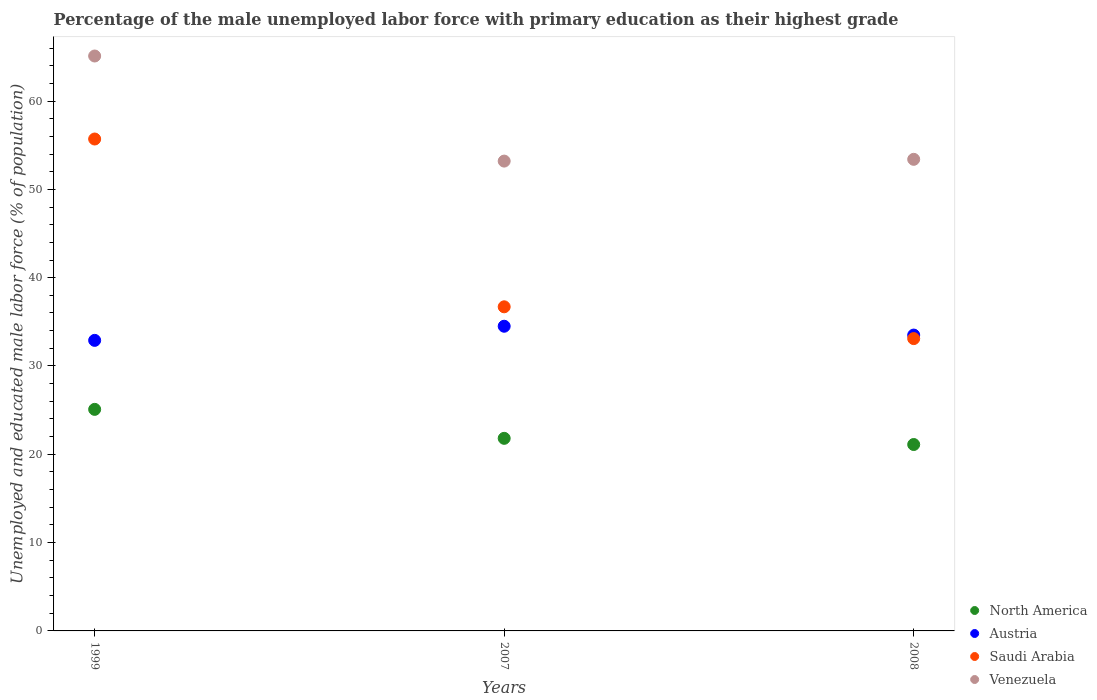What is the percentage of the unemployed male labor force with primary education in Austria in 1999?
Your answer should be compact. 32.9. Across all years, what is the maximum percentage of the unemployed male labor force with primary education in Venezuela?
Make the answer very short. 65.1. Across all years, what is the minimum percentage of the unemployed male labor force with primary education in Saudi Arabia?
Provide a succinct answer. 33.1. What is the total percentage of the unemployed male labor force with primary education in Saudi Arabia in the graph?
Offer a terse response. 125.5. What is the difference between the percentage of the unemployed male labor force with primary education in Austria in 1999 and that in 2008?
Provide a succinct answer. -0.6. What is the difference between the percentage of the unemployed male labor force with primary education in Venezuela in 2007 and the percentage of the unemployed male labor force with primary education in North America in 2008?
Offer a very short reply. 32.09. What is the average percentage of the unemployed male labor force with primary education in North America per year?
Your answer should be compact. 22.67. In the year 2008, what is the difference between the percentage of the unemployed male labor force with primary education in Venezuela and percentage of the unemployed male labor force with primary education in Saudi Arabia?
Provide a succinct answer. 20.3. In how many years, is the percentage of the unemployed male labor force with primary education in Saudi Arabia greater than 30 %?
Give a very brief answer. 3. What is the ratio of the percentage of the unemployed male labor force with primary education in Austria in 1999 to that in 2008?
Your answer should be compact. 0.98. Is the difference between the percentage of the unemployed male labor force with primary education in Venezuela in 2007 and 2008 greater than the difference between the percentage of the unemployed male labor force with primary education in Saudi Arabia in 2007 and 2008?
Provide a short and direct response. No. What is the difference between the highest and the second highest percentage of the unemployed male labor force with primary education in North America?
Keep it short and to the point. 3.28. What is the difference between the highest and the lowest percentage of the unemployed male labor force with primary education in North America?
Your answer should be compact. 3.98. In how many years, is the percentage of the unemployed male labor force with primary education in Venezuela greater than the average percentage of the unemployed male labor force with primary education in Venezuela taken over all years?
Your answer should be compact. 1. Is it the case that in every year, the sum of the percentage of the unemployed male labor force with primary education in Saudi Arabia and percentage of the unemployed male labor force with primary education in Austria  is greater than the sum of percentage of the unemployed male labor force with primary education in Venezuela and percentage of the unemployed male labor force with primary education in North America?
Your answer should be very brief. No. Is it the case that in every year, the sum of the percentage of the unemployed male labor force with primary education in Venezuela and percentage of the unemployed male labor force with primary education in Austria  is greater than the percentage of the unemployed male labor force with primary education in North America?
Offer a terse response. Yes. How many years are there in the graph?
Provide a short and direct response. 3. Are the values on the major ticks of Y-axis written in scientific E-notation?
Your response must be concise. No. How many legend labels are there?
Give a very brief answer. 4. How are the legend labels stacked?
Provide a short and direct response. Vertical. What is the title of the graph?
Your response must be concise. Percentage of the male unemployed labor force with primary education as their highest grade. Does "Liechtenstein" appear as one of the legend labels in the graph?
Offer a very short reply. No. What is the label or title of the Y-axis?
Provide a short and direct response. Unemployed and educated male labor force (% of population). What is the Unemployed and educated male labor force (% of population) of North America in 1999?
Give a very brief answer. 25.09. What is the Unemployed and educated male labor force (% of population) in Austria in 1999?
Provide a short and direct response. 32.9. What is the Unemployed and educated male labor force (% of population) in Saudi Arabia in 1999?
Your answer should be compact. 55.7. What is the Unemployed and educated male labor force (% of population) in Venezuela in 1999?
Make the answer very short. 65.1. What is the Unemployed and educated male labor force (% of population) in North America in 2007?
Provide a succinct answer. 21.81. What is the Unemployed and educated male labor force (% of population) of Austria in 2007?
Offer a terse response. 34.5. What is the Unemployed and educated male labor force (% of population) in Saudi Arabia in 2007?
Provide a short and direct response. 36.7. What is the Unemployed and educated male labor force (% of population) of Venezuela in 2007?
Provide a succinct answer. 53.2. What is the Unemployed and educated male labor force (% of population) in North America in 2008?
Make the answer very short. 21.11. What is the Unemployed and educated male labor force (% of population) of Austria in 2008?
Make the answer very short. 33.5. What is the Unemployed and educated male labor force (% of population) in Saudi Arabia in 2008?
Your answer should be compact. 33.1. What is the Unemployed and educated male labor force (% of population) of Venezuela in 2008?
Provide a succinct answer. 53.4. Across all years, what is the maximum Unemployed and educated male labor force (% of population) in North America?
Offer a terse response. 25.09. Across all years, what is the maximum Unemployed and educated male labor force (% of population) in Austria?
Make the answer very short. 34.5. Across all years, what is the maximum Unemployed and educated male labor force (% of population) of Saudi Arabia?
Your response must be concise. 55.7. Across all years, what is the maximum Unemployed and educated male labor force (% of population) in Venezuela?
Keep it short and to the point. 65.1. Across all years, what is the minimum Unemployed and educated male labor force (% of population) in North America?
Offer a very short reply. 21.11. Across all years, what is the minimum Unemployed and educated male labor force (% of population) in Austria?
Your answer should be compact. 32.9. Across all years, what is the minimum Unemployed and educated male labor force (% of population) of Saudi Arabia?
Keep it short and to the point. 33.1. Across all years, what is the minimum Unemployed and educated male labor force (% of population) of Venezuela?
Offer a very short reply. 53.2. What is the total Unemployed and educated male labor force (% of population) in North America in the graph?
Your answer should be very brief. 68. What is the total Unemployed and educated male labor force (% of population) of Austria in the graph?
Make the answer very short. 100.9. What is the total Unemployed and educated male labor force (% of population) in Saudi Arabia in the graph?
Ensure brevity in your answer.  125.5. What is the total Unemployed and educated male labor force (% of population) in Venezuela in the graph?
Make the answer very short. 171.7. What is the difference between the Unemployed and educated male labor force (% of population) in North America in 1999 and that in 2007?
Ensure brevity in your answer.  3.28. What is the difference between the Unemployed and educated male labor force (% of population) in Austria in 1999 and that in 2007?
Provide a succinct answer. -1.6. What is the difference between the Unemployed and educated male labor force (% of population) in Saudi Arabia in 1999 and that in 2007?
Your response must be concise. 19. What is the difference between the Unemployed and educated male labor force (% of population) in Venezuela in 1999 and that in 2007?
Make the answer very short. 11.9. What is the difference between the Unemployed and educated male labor force (% of population) of North America in 1999 and that in 2008?
Ensure brevity in your answer.  3.98. What is the difference between the Unemployed and educated male labor force (% of population) in Saudi Arabia in 1999 and that in 2008?
Your answer should be compact. 22.6. What is the difference between the Unemployed and educated male labor force (% of population) in North America in 2007 and that in 2008?
Ensure brevity in your answer.  0.7. What is the difference between the Unemployed and educated male labor force (% of population) in Austria in 2007 and that in 2008?
Provide a succinct answer. 1. What is the difference between the Unemployed and educated male labor force (% of population) of Saudi Arabia in 2007 and that in 2008?
Provide a succinct answer. 3.6. What is the difference between the Unemployed and educated male labor force (% of population) in Venezuela in 2007 and that in 2008?
Your response must be concise. -0.2. What is the difference between the Unemployed and educated male labor force (% of population) of North America in 1999 and the Unemployed and educated male labor force (% of population) of Austria in 2007?
Provide a short and direct response. -9.41. What is the difference between the Unemployed and educated male labor force (% of population) in North America in 1999 and the Unemployed and educated male labor force (% of population) in Saudi Arabia in 2007?
Offer a terse response. -11.61. What is the difference between the Unemployed and educated male labor force (% of population) of North America in 1999 and the Unemployed and educated male labor force (% of population) of Venezuela in 2007?
Provide a succinct answer. -28.11. What is the difference between the Unemployed and educated male labor force (% of population) in Austria in 1999 and the Unemployed and educated male labor force (% of population) in Saudi Arabia in 2007?
Give a very brief answer. -3.8. What is the difference between the Unemployed and educated male labor force (% of population) of Austria in 1999 and the Unemployed and educated male labor force (% of population) of Venezuela in 2007?
Give a very brief answer. -20.3. What is the difference between the Unemployed and educated male labor force (% of population) of Saudi Arabia in 1999 and the Unemployed and educated male labor force (% of population) of Venezuela in 2007?
Give a very brief answer. 2.5. What is the difference between the Unemployed and educated male labor force (% of population) in North America in 1999 and the Unemployed and educated male labor force (% of population) in Austria in 2008?
Your response must be concise. -8.41. What is the difference between the Unemployed and educated male labor force (% of population) in North America in 1999 and the Unemployed and educated male labor force (% of population) in Saudi Arabia in 2008?
Ensure brevity in your answer.  -8.01. What is the difference between the Unemployed and educated male labor force (% of population) of North America in 1999 and the Unemployed and educated male labor force (% of population) of Venezuela in 2008?
Give a very brief answer. -28.31. What is the difference between the Unemployed and educated male labor force (% of population) of Austria in 1999 and the Unemployed and educated male labor force (% of population) of Saudi Arabia in 2008?
Keep it short and to the point. -0.2. What is the difference between the Unemployed and educated male labor force (% of population) in Austria in 1999 and the Unemployed and educated male labor force (% of population) in Venezuela in 2008?
Your answer should be compact. -20.5. What is the difference between the Unemployed and educated male labor force (% of population) of Saudi Arabia in 1999 and the Unemployed and educated male labor force (% of population) of Venezuela in 2008?
Your answer should be compact. 2.3. What is the difference between the Unemployed and educated male labor force (% of population) of North America in 2007 and the Unemployed and educated male labor force (% of population) of Austria in 2008?
Give a very brief answer. -11.69. What is the difference between the Unemployed and educated male labor force (% of population) of North America in 2007 and the Unemployed and educated male labor force (% of population) of Saudi Arabia in 2008?
Your answer should be compact. -11.29. What is the difference between the Unemployed and educated male labor force (% of population) in North America in 2007 and the Unemployed and educated male labor force (% of population) in Venezuela in 2008?
Give a very brief answer. -31.59. What is the difference between the Unemployed and educated male labor force (% of population) of Austria in 2007 and the Unemployed and educated male labor force (% of population) of Saudi Arabia in 2008?
Make the answer very short. 1.4. What is the difference between the Unemployed and educated male labor force (% of population) in Austria in 2007 and the Unemployed and educated male labor force (% of population) in Venezuela in 2008?
Give a very brief answer. -18.9. What is the difference between the Unemployed and educated male labor force (% of population) of Saudi Arabia in 2007 and the Unemployed and educated male labor force (% of population) of Venezuela in 2008?
Offer a very short reply. -16.7. What is the average Unemployed and educated male labor force (% of population) of North America per year?
Ensure brevity in your answer.  22.67. What is the average Unemployed and educated male labor force (% of population) in Austria per year?
Ensure brevity in your answer.  33.63. What is the average Unemployed and educated male labor force (% of population) in Saudi Arabia per year?
Your answer should be compact. 41.83. What is the average Unemployed and educated male labor force (% of population) in Venezuela per year?
Keep it short and to the point. 57.23. In the year 1999, what is the difference between the Unemployed and educated male labor force (% of population) of North America and Unemployed and educated male labor force (% of population) of Austria?
Provide a short and direct response. -7.81. In the year 1999, what is the difference between the Unemployed and educated male labor force (% of population) in North America and Unemployed and educated male labor force (% of population) in Saudi Arabia?
Provide a short and direct response. -30.61. In the year 1999, what is the difference between the Unemployed and educated male labor force (% of population) of North America and Unemployed and educated male labor force (% of population) of Venezuela?
Give a very brief answer. -40.01. In the year 1999, what is the difference between the Unemployed and educated male labor force (% of population) in Austria and Unemployed and educated male labor force (% of population) in Saudi Arabia?
Your response must be concise. -22.8. In the year 1999, what is the difference between the Unemployed and educated male labor force (% of population) in Austria and Unemployed and educated male labor force (% of population) in Venezuela?
Your answer should be very brief. -32.2. In the year 1999, what is the difference between the Unemployed and educated male labor force (% of population) in Saudi Arabia and Unemployed and educated male labor force (% of population) in Venezuela?
Your answer should be compact. -9.4. In the year 2007, what is the difference between the Unemployed and educated male labor force (% of population) of North America and Unemployed and educated male labor force (% of population) of Austria?
Offer a terse response. -12.69. In the year 2007, what is the difference between the Unemployed and educated male labor force (% of population) in North America and Unemployed and educated male labor force (% of population) in Saudi Arabia?
Provide a succinct answer. -14.89. In the year 2007, what is the difference between the Unemployed and educated male labor force (% of population) in North America and Unemployed and educated male labor force (% of population) in Venezuela?
Provide a short and direct response. -31.39. In the year 2007, what is the difference between the Unemployed and educated male labor force (% of population) of Austria and Unemployed and educated male labor force (% of population) of Venezuela?
Offer a terse response. -18.7. In the year 2007, what is the difference between the Unemployed and educated male labor force (% of population) in Saudi Arabia and Unemployed and educated male labor force (% of population) in Venezuela?
Provide a succinct answer. -16.5. In the year 2008, what is the difference between the Unemployed and educated male labor force (% of population) in North America and Unemployed and educated male labor force (% of population) in Austria?
Make the answer very short. -12.39. In the year 2008, what is the difference between the Unemployed and educated male labor force (% of population) in North America and Unemployed and educated male labor force (% of population) in Saudi Arabia?
Offer a very short reply. -11.99. In the year 2008, what is the difference between the Unemployed and educated male labor force (% of population) in North America and Unemployed and educated male labor force (% of population) in Venezuela?
Ensure brevity in your answer.  -32.29. In the year 2008, what is the difference between the Unemployed and educated male labor force (% of population) in Austria and Unemployed and educated male labor force (% of population) in Saudi Arabia?
Offer a terse response. 0.4. In the year 2008, what is the difference between the Unemployed and educated male labor force (% of population) in Austria and Unemployed and educated male labor force (% of population) in Venezuela?
Offer a terse response. -19.9. In the year 2008, what is the difference between the Unemployed and educated male labor force (% of population) in Saudi Arabia and Unemployed and educated male labor force (% of population) in Venezuela?
Provide a short and direct response. -20.3. What is the ratio of the Unemployed and educated male labor force (% of population) of North America in 1999 to that in 2007?
Your response must be concise. 1.15. What is the ratio of the Unemployed and educated male labor force (% of population) in Austria in 1999 to that in 2007?
Ensure brevity in your answer.  0.95. What is the ratio of the Unemployed and educated male labor force (% of population) in Saudi Arabia in 1999 to that in 2007?
Provide a succinct answer. 1.52. What is the ratio of the Unemployed and educated male labor force (% of population) of Venezuela in 1999 to that in 2007?
Your answer should be compact. 1.22. What is the ratio of the Unemployed and educated male labor force (% of population) in North America in 1999 to that in 2008?
Keep it short and to the point. 1.19. What is the ratio of the Unemployed and educated male labor force (% of population) in Austria in 1999 to that in 2008?
Make the answer very short. 0.98. What is the ratio of the Unemployed and educated male labor force (% of population) of Saudi Arabia in 1999 to that in 2008?
Your response must be concise. 1.68. What is the ratio of the Unemployed and educated male labor force (% of population) of Venezuela in 1999 to that in 2008?
Ensure brevity in your answer.  1.22. What is the ratio of the Unemployed and educated male labor force (% of population) in North America in 2007 to that in 2008?
Ensure brevity in your answer.  1.03. What is the ratio of the Unemployed and educated male labor force (% of population) of Austria in 2007 to that in 2008?
Provide a succinct answer. 1.03. What is the ratio of the Unemployed and educated male labor force (% of population) of Saudi Arabia in 2007 to that in 2008?
Keep it short and to the point. 1.11. What is the difference between the highest and the second highest Unemployed and educated male labor force (% of population) in North America?
Offer a very short reply. 3.28. What is the difference between the highest and the second highest Unemployed and educated male labor force (% of population) in Austria?
Keep it short and to the point. 1. What is the difference between the highest and the second highest Unemployed and educated male labor force (% of population) of Saudi Arabia?
Offer a terse response. 19. What is the difference between the highest and the lowest Unemployed and educated male labor force (% of population) of North America?
Your response must be concise. 3.98. What is the difference between the highest and the lowest Unemployed and educated male labor force (% of population) in Austria?
Keep it short and to the point. 1.6. What is the difference between the highest and the lowest Unemployed and educated male labor force (% of population) of Saudi Arabia?
Your answer should be very brief. 22.6. What is the difference between the highest and the lowest Unemployed and educated male labor force (% of population) of Venezuela?
Provide a short and direct response. 11.9. 